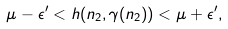Convert formula to latex. <formula><loc_0><loc_0><loc_500><loc_500>\mu - \epsilon ^ { \prime } < h ( n _ { 2 } , \gamma ( n _ { 2 } ) ) < \mu + \epsilon ^ { \prime } ,</formula> 